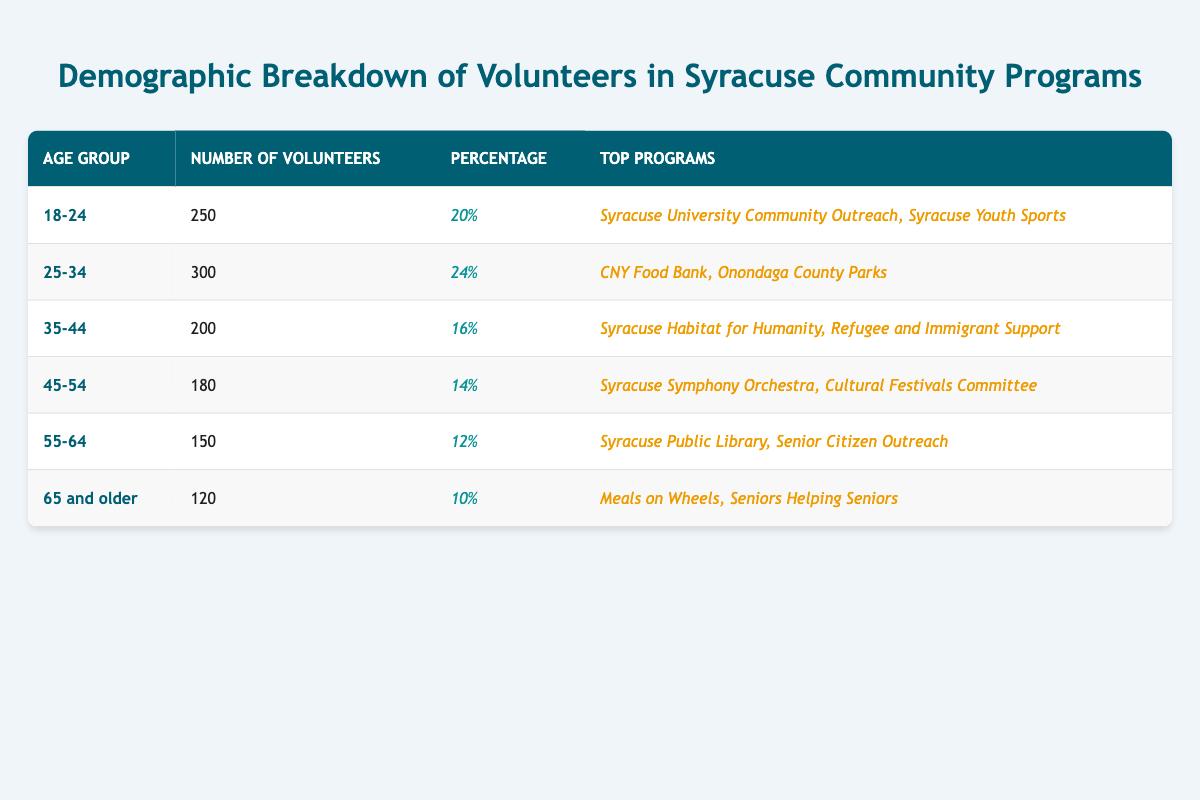What percentage of volunteers are aged 25-34? According to the table, the percentage of volunteers in the age group 25-34 is listed as 24%.
Answer: 24% How many volunteers are there in the age group 45-54? The table indicates that there are 180 volunteers in the age group 45-54.
Answer: 180 What is the total number of volunteers across all age groups? Adding the number of volunteers from each age group gives us: 250 + 300 + 200 + 180 + 150 + 120 = 1200.
Answer: 1200 Which age group has the highest number of volunteers? By examining the table, the age group with the highest number of volunteers is 25-34, with 300 volunteers.
Answer: 25-34 Is the number of volunteers older than 55 less than the number of volunteers aged 18-24? The number of volunteers aged 55-64 is 150 and those aged 65 and older is 120, giving a total of 270. Since 270 is greater than 250, the statement is false.
Answer: No What is the difference in the number of volunteers between the age groups 18-24 and 35-44? The difference can be calculated as: 250 (age 18-24) - 200 (age 35-44) = 50.
Answer: 50 What age group makes up the smallest percentage of volunteers? The age group with the smallest percentage is 65 and older, which has 10%.
Answer: 10% What is the average number of volunteers per age group? To find the average, we take the total number of volunteers (1200) and divide it by the number of age groups (6): 1200 / 6 = 200.
Answer: 200 Are there more volunteers in the age group 35-44 or in the age group 55-64? The table shows that there are 200 volunteers in the age group 35-44 and 150 in the age group 55-64, indicating that there are more in the 35-44 age group.
Answer: Yes What proportion of volunteers participate in the top program for ages 18-24 compared to the total number of volunteers? There are 250 volunteers in the 18-24 age group. To find the proportion, we divide 250 by 1200 (total volunteers): 250 / 1200 = 0.2083, or approximately 21%.
Answer: 21% 